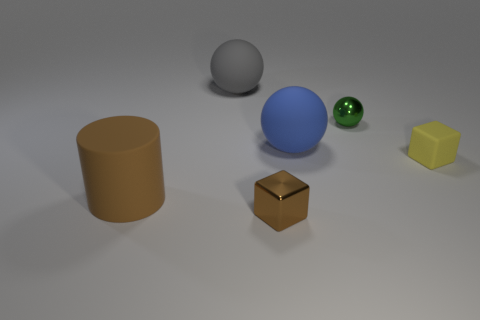Add 1 large blue metal balls. How many objects exist? 7 Subtract all cylinders. How many objects are left? 5 Add 3 cubes. How many cubes exist? 5 Subtract 0 red balls. How many objects are left? 6 Subtract all big red rubber objects. Subtract all blue rubber balls. How many objects are left? 5 Add 4 tiny cubes. How many tiny cubes are left? 6 